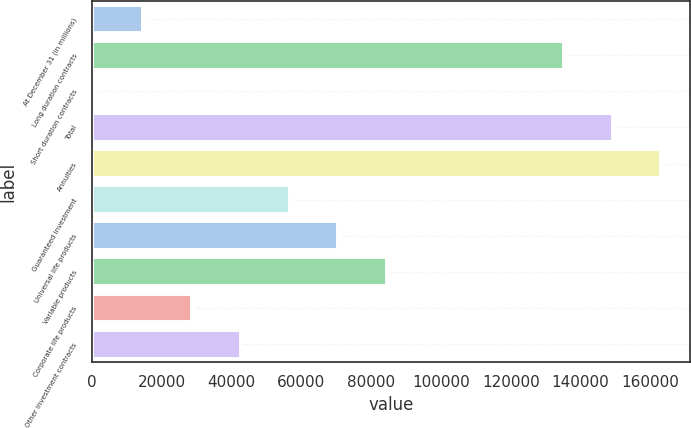<chart> <loc_0><loc_0><loc_500><loc_500><bar_chart><fcel>At December 31 (in millions)<fcel>Long duration contracts<fcel>Short duration contracts<fcel>Total<fcel>Annuities<fcel>Guaranteed investment<fcel>Universal life products<fcel>Variable products<fcel>Corporate life products<fcel>Other investment contracts<nl><fcel>14823.8<fcel>135202<fcel>866<fcel>149160<fcel>163118<fcel>56697.2<fcel>70655<fcel>84612.8<fcel>28781.6<fcel>42739.4<nl></chart> 